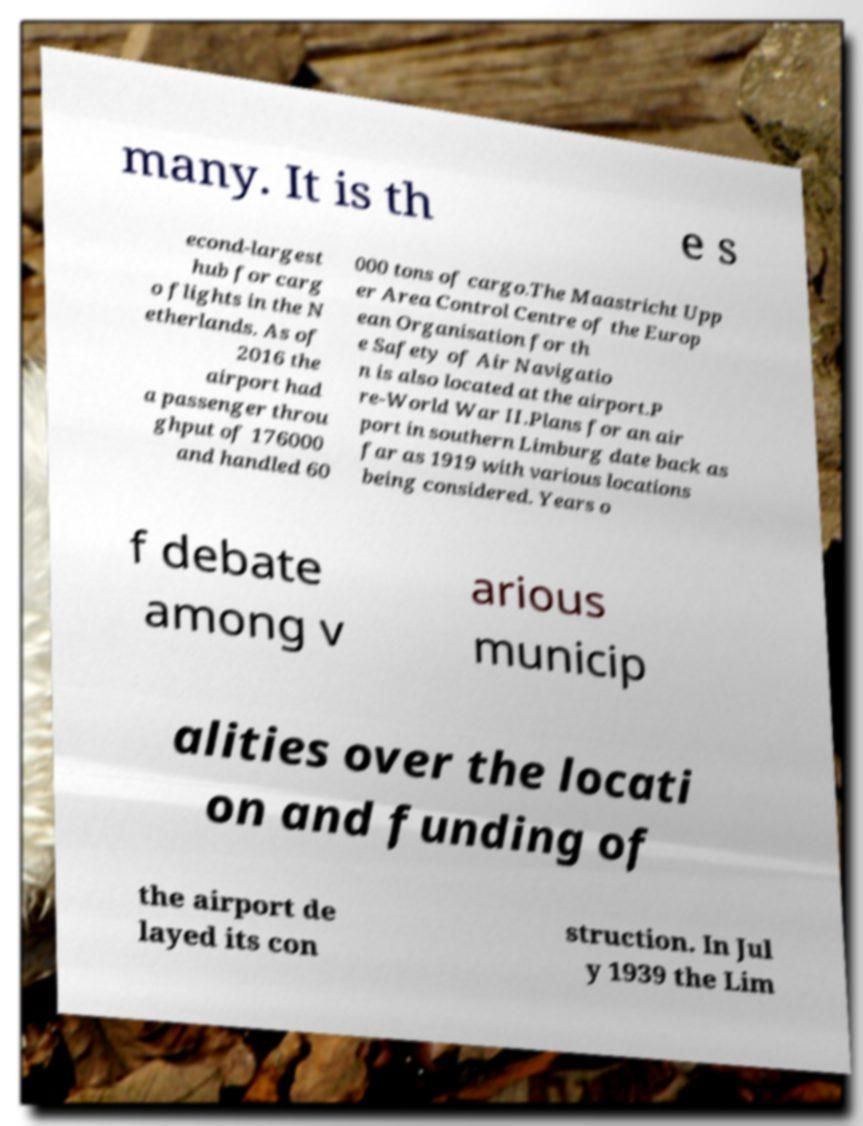There's text embedded in this image that I need extracted. Can you transcribe it verbatim? many. It is th e s econd-largest hub for carg o flights in the N etherlands. As of 2016 the airport had a passenger throu ghput of 176000 and handled 60 000 tons of cargo.The Maastricht Upp er Area Control Centre of the Europ ean Organisation for th e Safety of Air Navigatio n is also located at the airport.P re-World War II.Plans for an air port in southern Limburg date back as far as 1919 with various locations being considered. Years o f debate among v arious municip alities over the locati on and funding of the airport de layed its con struction. In Jul y 1939 the Lim 